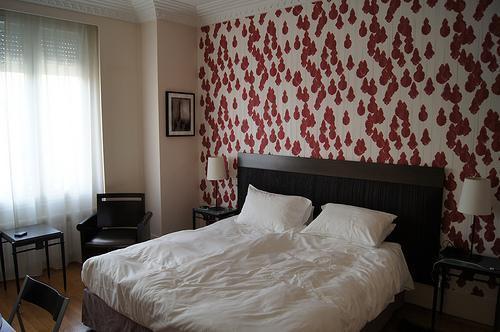How many pillows on bed?
Give a very brief answer. 2. 